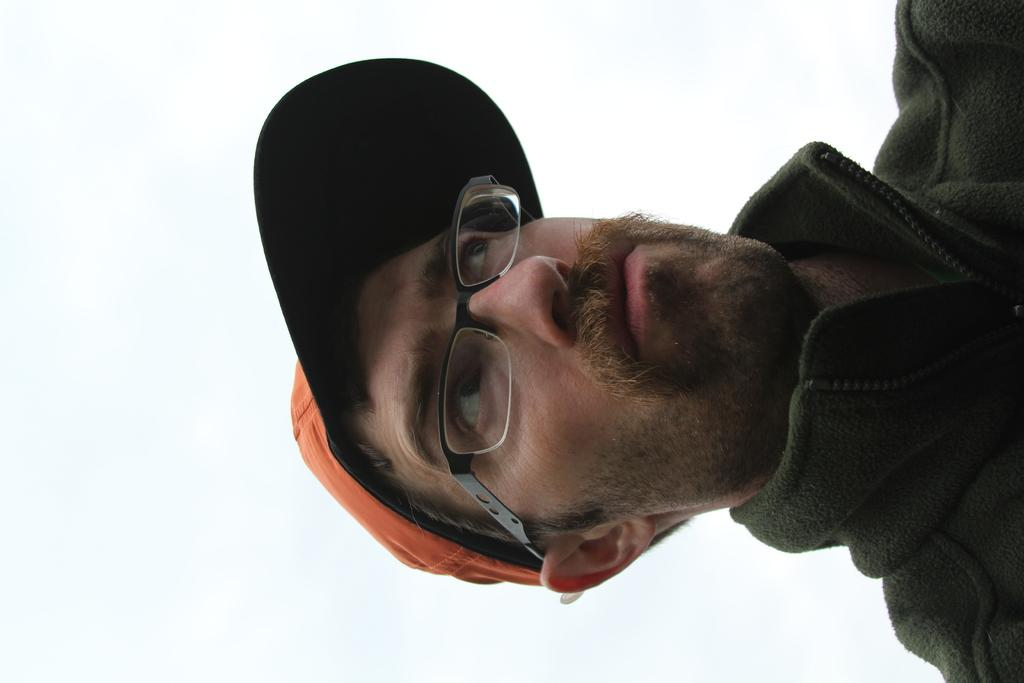What is the main subject of the image? There is a person in the center of the image. What is the person wearing on their head? The person is wearing an orange cap. What type of clothing is the person wearing on their upper body? The person is wearing a jacket. How many cherries can be seen in the person's hand in the image? There are no cherries present in the image. What is the person's son doing in the background of the image? There is no son or background depicted in the image; it only shows a person wearing an orange cap and a jacket. 